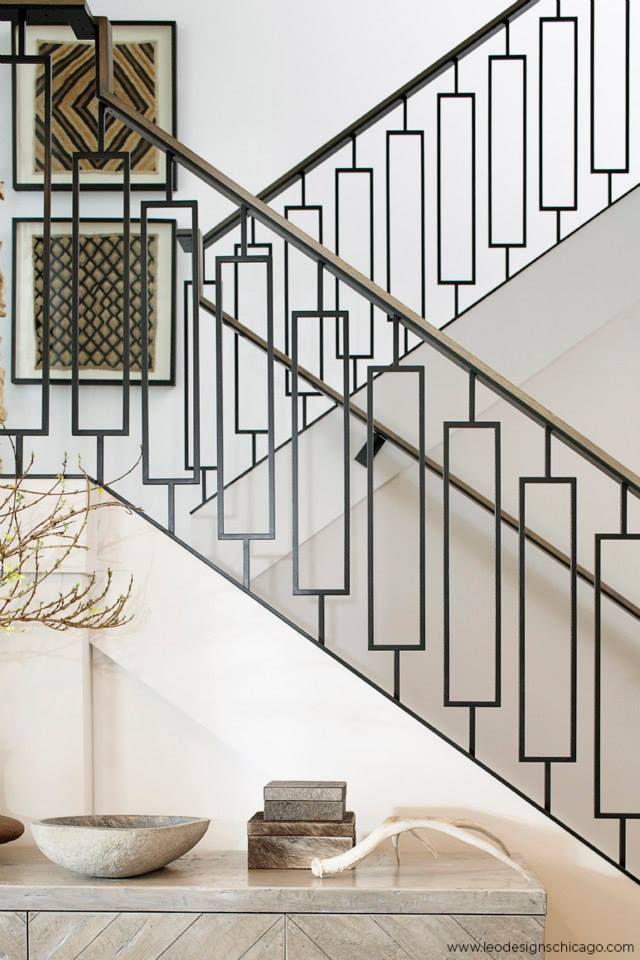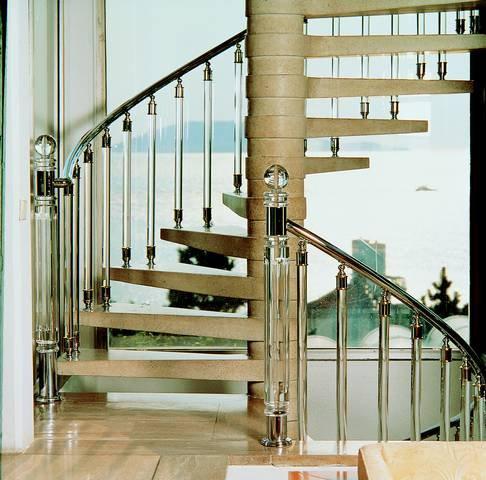The first image is the image on the left, the second image is the image on the right. Evaluate the accuracy of this statement regarding the images: "One image features backless stairs that ascend in a spiral pattern from an upright pole in the center.". Is it true? Answer yes or no. Yes. The first image is the image on the left, the second image is the image on the right. Analyze the images presented: Is the assertion "The staircase in one of the images spirals its way down." valid? Answer yes or no. Yes. 